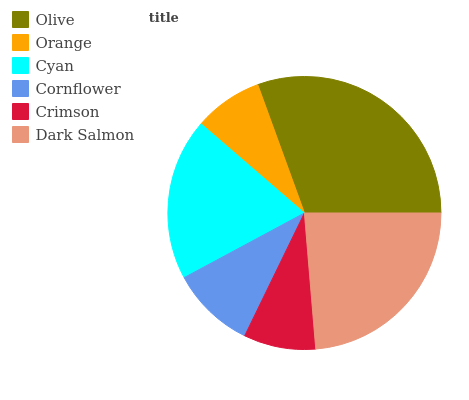Is Orange the minimum?
Answer yes or no. Yes. Is Olive the maximum?
Answer yes or no. Yes. Is Cyan the minimum?
Answer yes or no. No. Is Cyan the maximum?
Answer yes or no. No. Is Cyan greater than Orange?
Answer yes or no. Yes. Is Orange less than Cyan?
Answer yes or no. Yes. Is Orange greater than Cyan?
Answer yes or no. No. Is Cyan less than Orange?
Answer yes or no. No. Is Cyan the high median?
Answer yes or no. Yes. Is Cornflower the low median?
Answer yes or no. Yes. Is Olive the high median?
Answer yes or no. No. Is Crimson the low median?
Answer yes or no. No. 